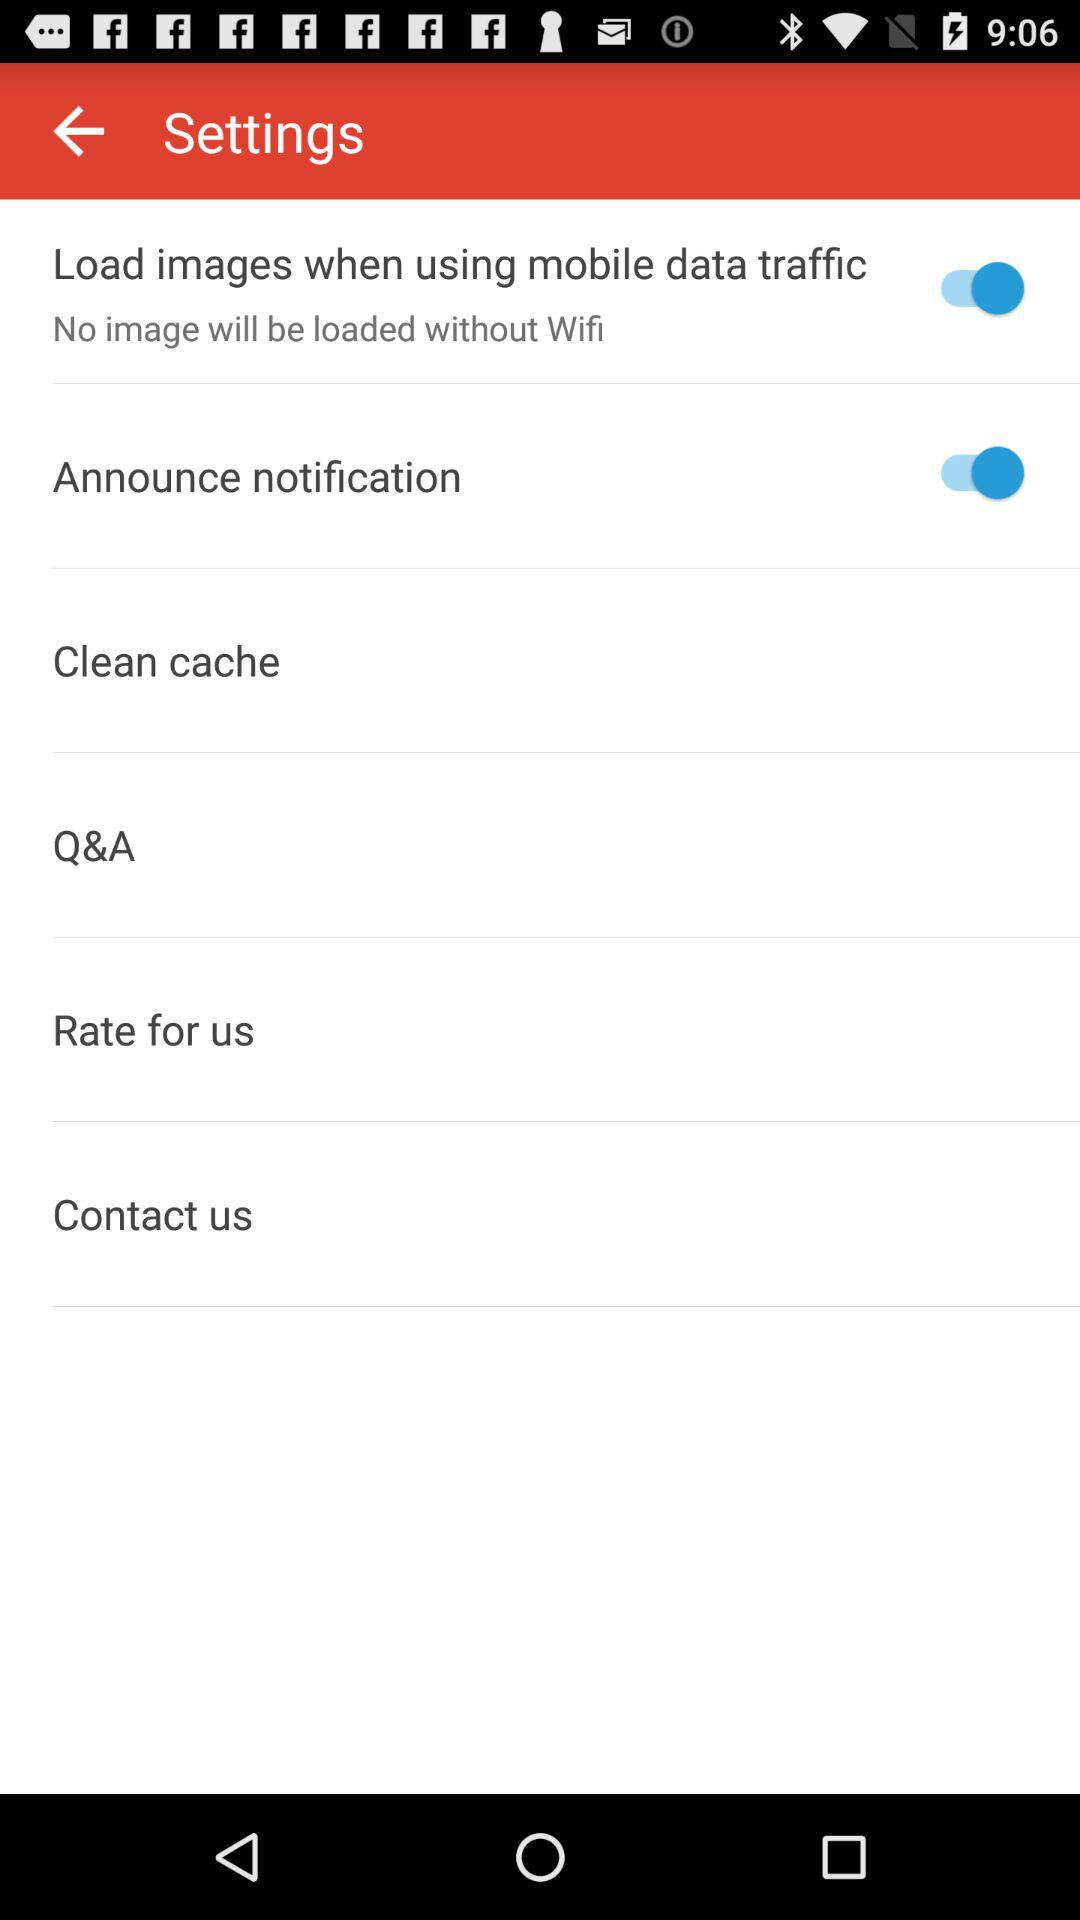What is the status of the "Announce notification"? The status is "on". 